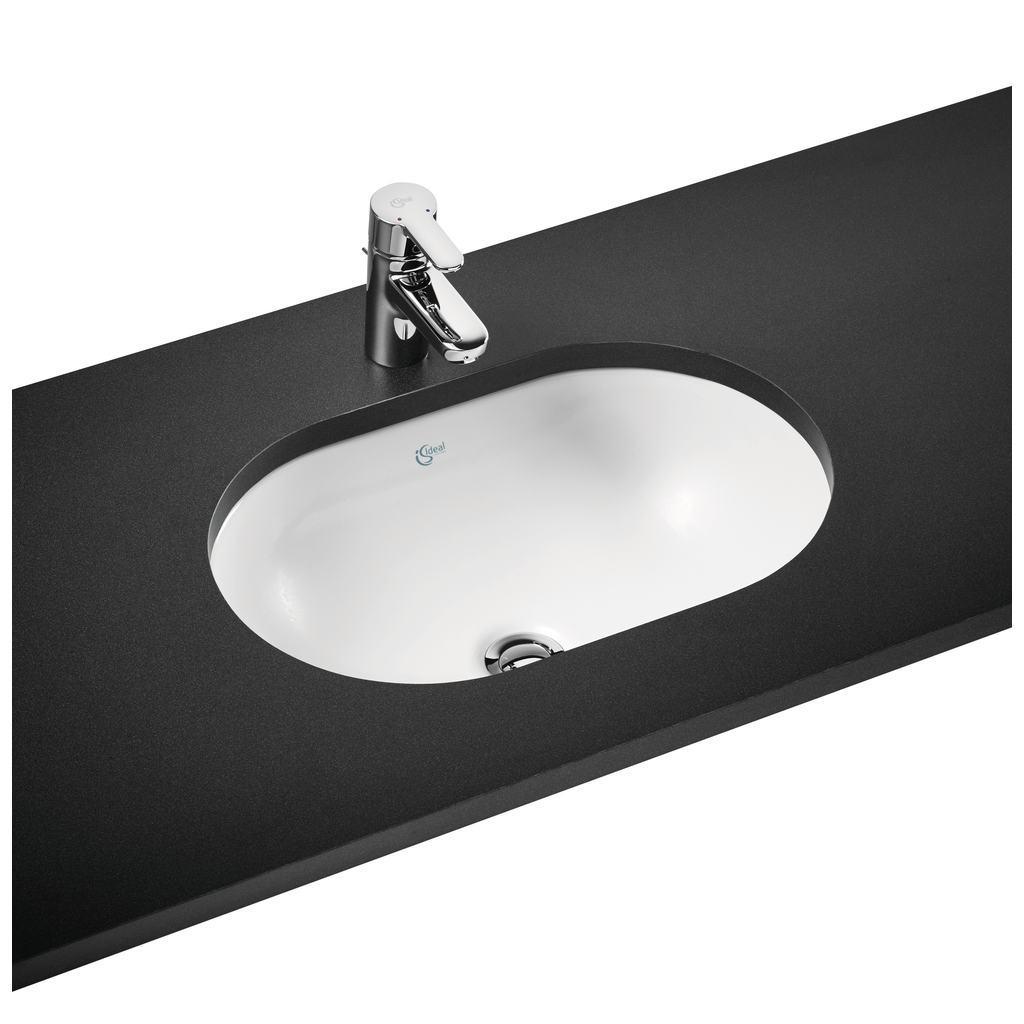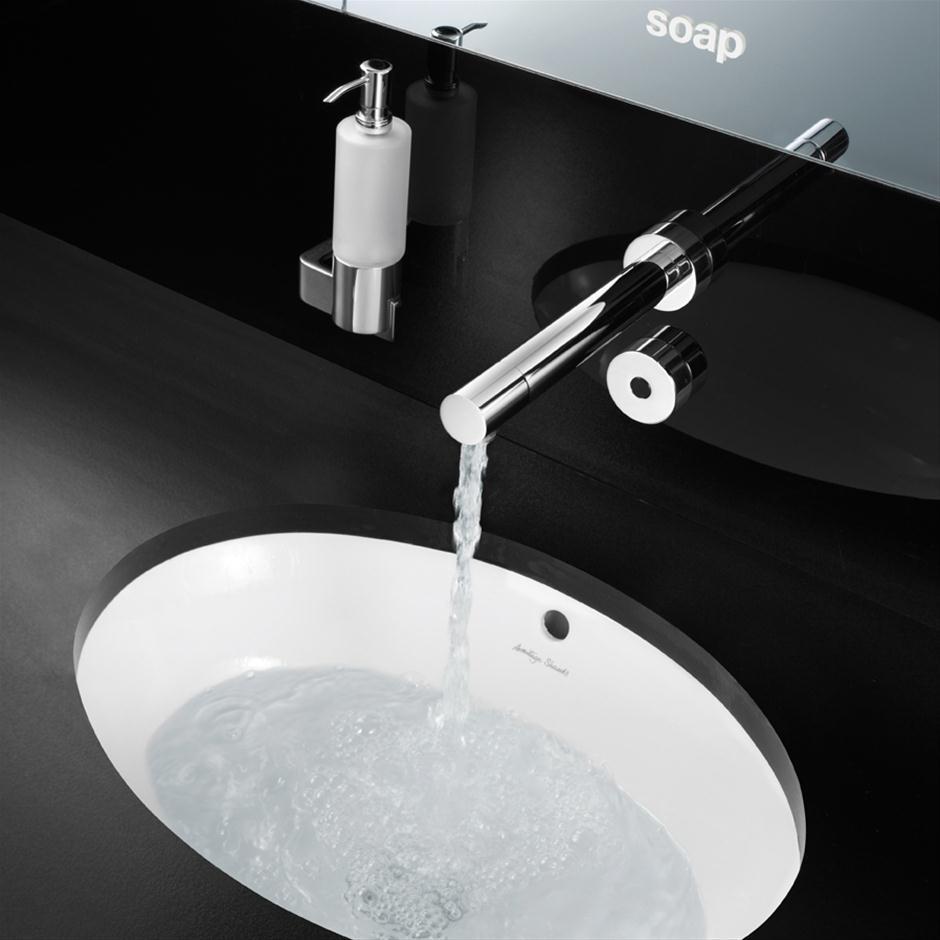The first image is the image on the left, the second image is the image on the right. Evaluate the accuracy of this statement regarding the images: "There are two sinks with black countertops.". Is it true? Answer yes or no. Yes. 